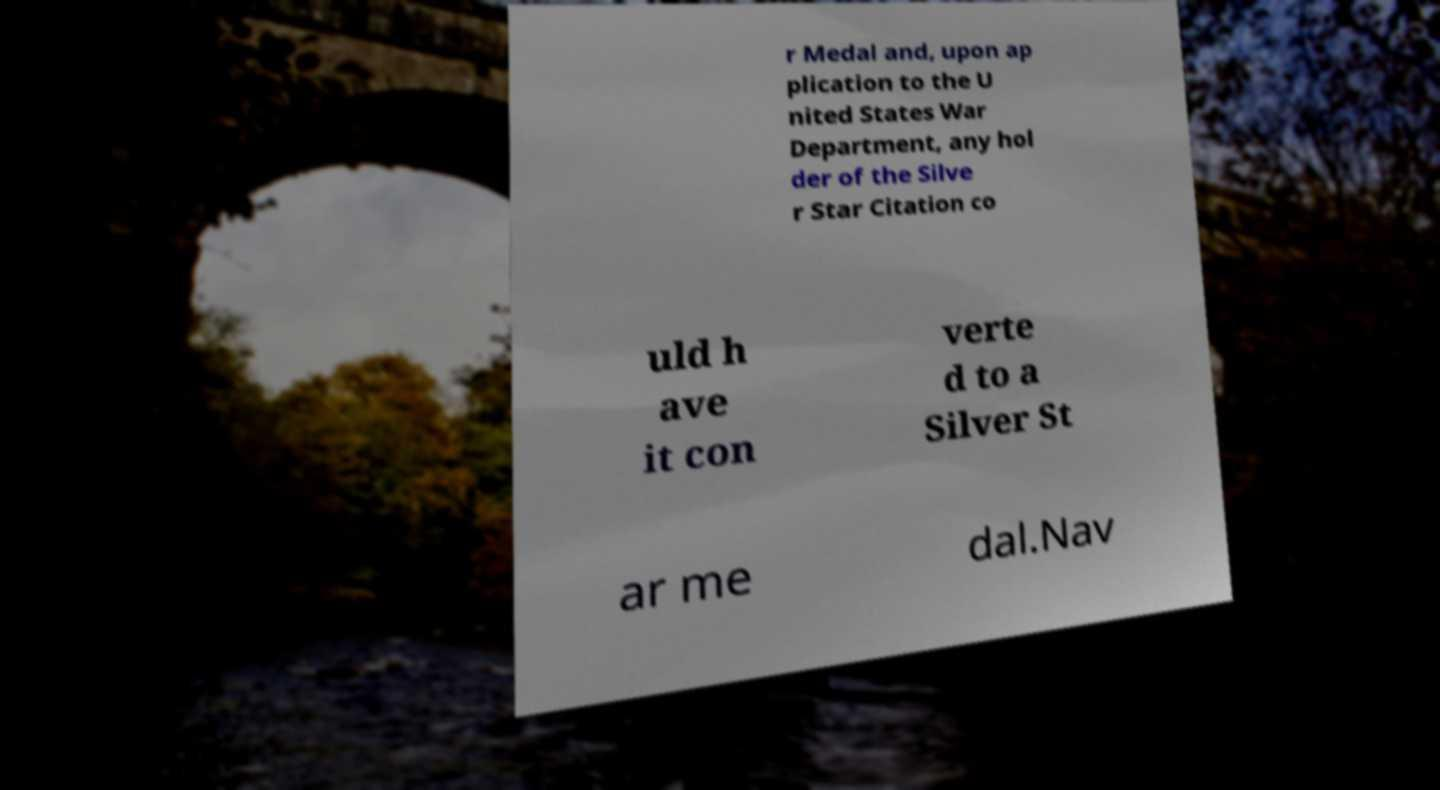There's text embedded in this image that I need extracted. Can you transcribe it verbatim? r Medal and, upon ap plication to the U nited States War Department, any hol der of the Silve r Star Citation co uld h ave it con verte d to a Silver St ar me dal.Nav 